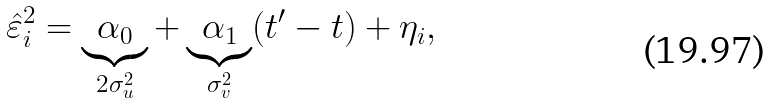<formula> <loc_0><loc_0><loc_500><loc_500>\hat { \varepsilon } _ { i } ^ { 2 } = \underbrace { \alpha _ { 0 } } _ { 2 \sigma ^ { 2 } _ { u } } + \underbrace { \alpha _ { 1 } } _ { \sigma ^ { 2 } _ { v } } ( t ^ { \prime } - t ) + \eta _ { i } ,</formula> 